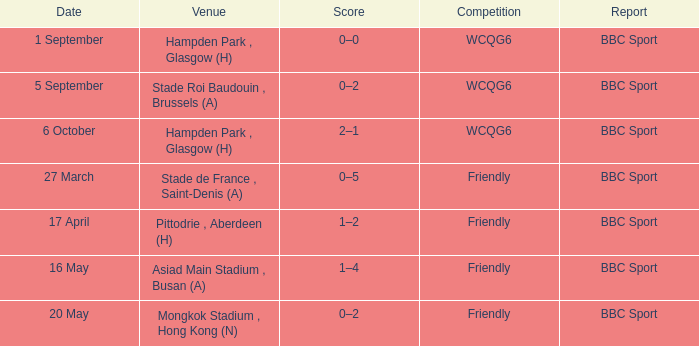What was the tally of the contest on 1 september? 0–0. 